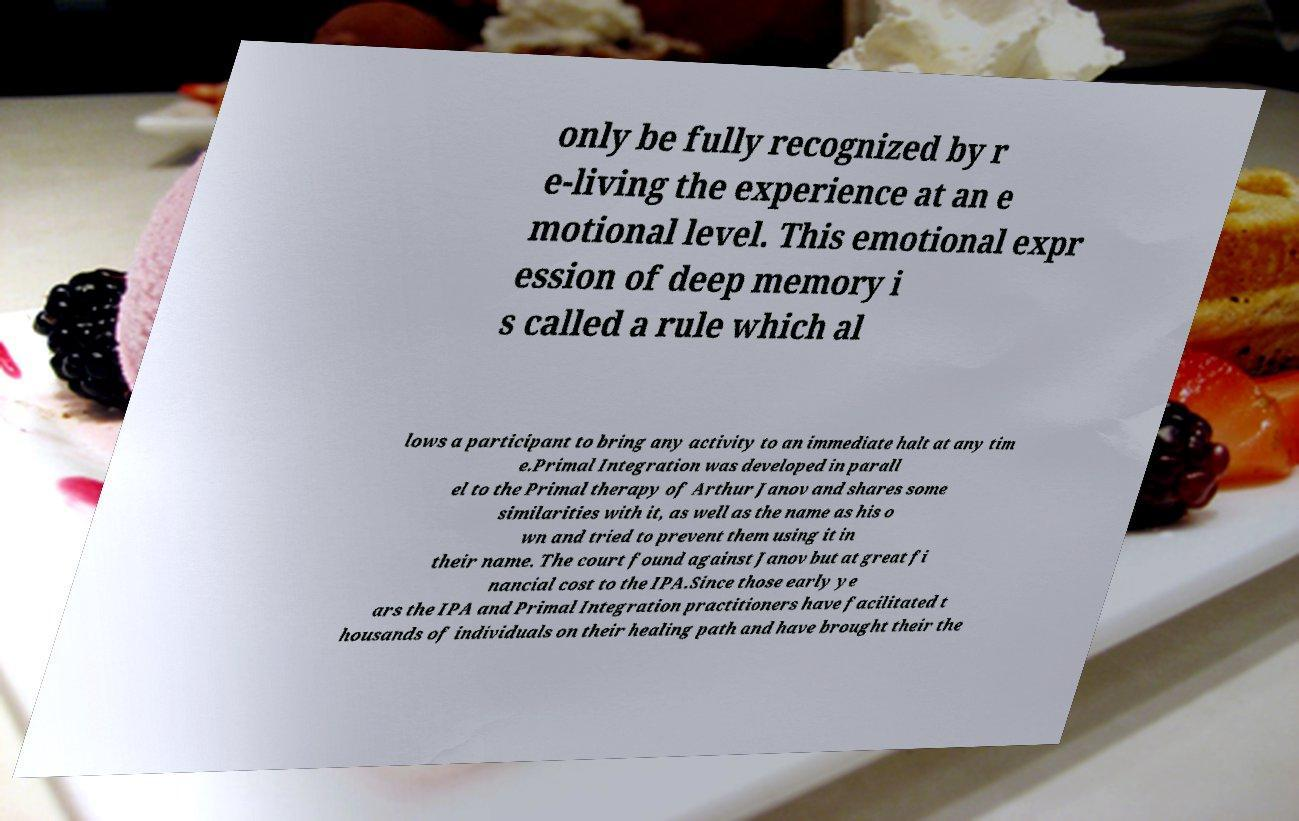There's text embedded in this image that I need extracted. Can you transcribe it verbatim? only be fully recognized by r e-living the experience at an e motional level. This emotional expr ession of deep memory i s called a rule which al lows a participant to bring any activity to an immediate halt at any tim e.Primal Integration was developed in parall el to the Primal therapy of Arthur Janov and shares some similarities with it, as well as the name as his o wn and tried to prevent them using it in their name. The court found against Janov but at great fi nancial cost to the IPA.Since those early ye ars the IPA and Primal Integration practitioners have facilitated t housands of individuals on their healing path and have brought their the 